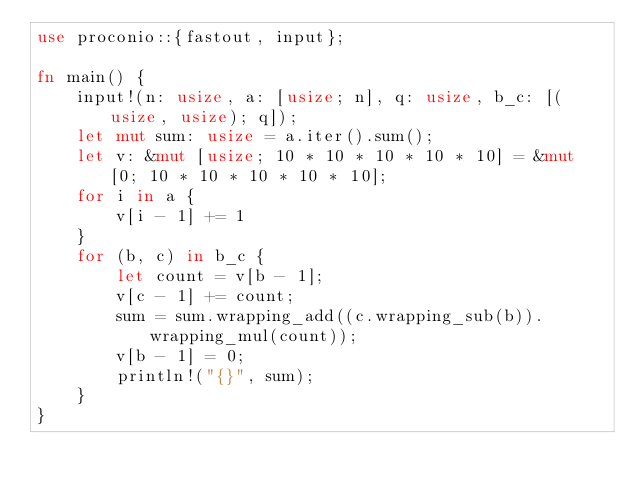Convert code to text. <code><loc_0><loc_0><loc_500><loc_500><_Rust_>use proconio::{fastout, input};

fn main() {
    input!(n: usize, a: [usize; n], q: usize, b_c: [(usize, usize); q]);
    let mut sum: usize = a.iter().sum();
    let v: &mut [usize; 10 * 10 * 10 * 10 * 10] = &mut [0; 10 * 10 * 10 * 10 * 10];
    for i in a {
        v[i - 1] += 1
    }
    for (b, c) in b_c {
        let count = v[b - 1];
        v[c - 1] += count;
        sum = sum.wrapping_add((c.wrapping_sub(b)).wrapping_mul(count));
        v[b - 1] = 0;
        println!("{}", sum);
    }
}
</code> 